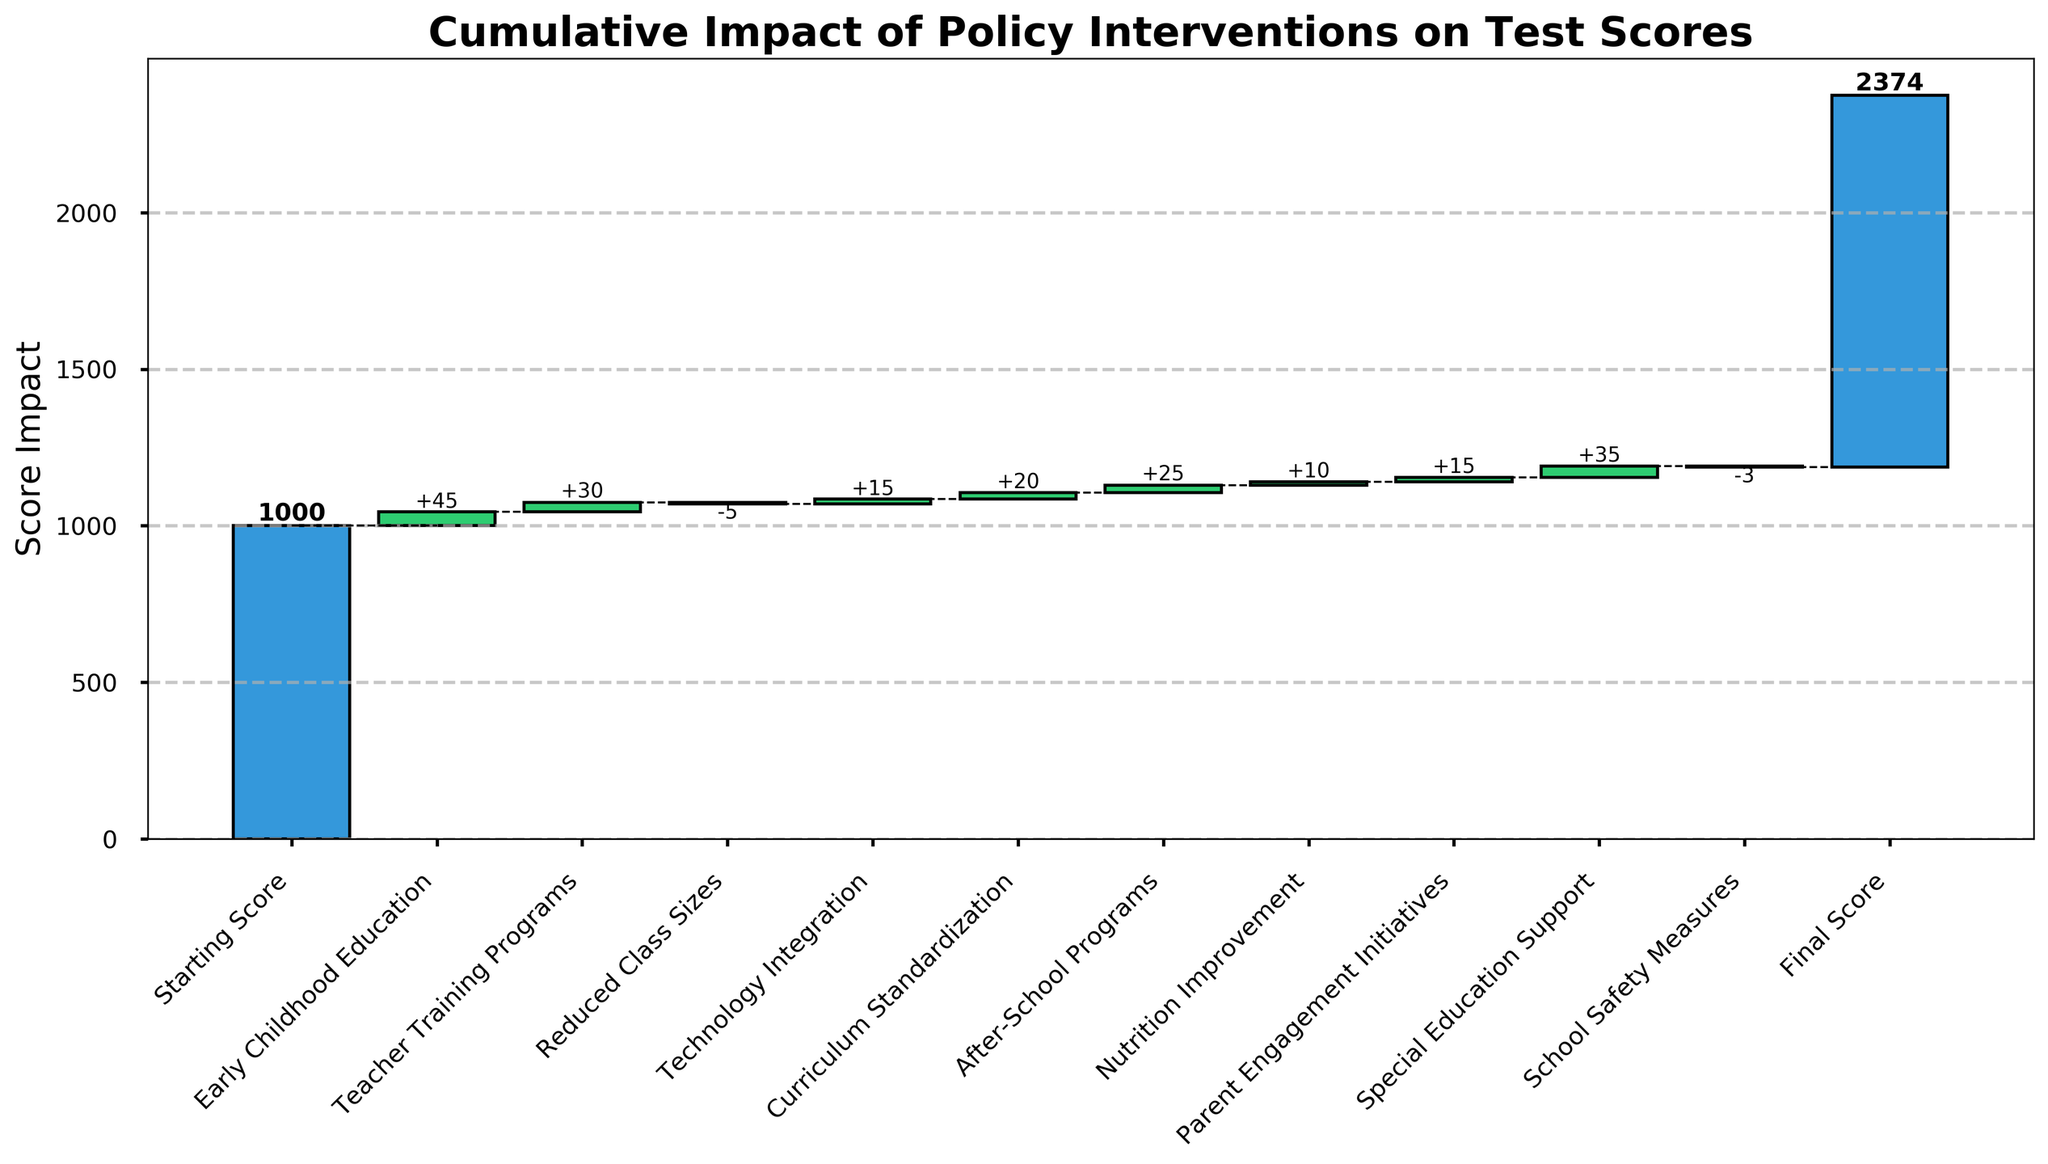What's the title of the chart? The title of the chart is the largest text at the top, which describes the purpose of the figure. It reads, "Cumulative Impact of Policy Interventions on Test Scores".
Answer: Cumulative Impact of Policy Interventions on Test Scores How many policy interventions are depicted in the figure? The figure lists each policy intervention along the x-axis. Counting all the bars on this axis including the starting and final scores, there are 11 items.
Answer: 11 Which policy intervention has the highest positive impact? By examining the height of the bars and their labels, we see that "Special Education Support" has the tallest bar among the intermediaries, indicating a positive impact of +35.
Answer: Special Education Support What is the initial score before any policy interventions? The first bar, labeled "Starting Score", indicates the initial score. The text within the bar confirms it is 1000.
Answer: 1000 What is the final score after all policy interventions? The last bar in the figure, which is labeled "Final Score", shows the cumulative result of all prior impacts. The label within this bar indicates a final score of 1187.
Answer: 1187 Which policy intervention is depicted to have a negative impact? By inspecting the color of the bars and their associated labels, "Reduced Class Sizes" is marked with a negative impact of -5, shown in red.
Answer: Reduced Class Sizes What is the cumulative impact of "Early Childhood Education", "Teacher Training Programs", and "After-School Programs" combined? Sum the impacts of these interventions: 45 (Early Childhood Education) + 30 (Teacher Training Programs) + 25 (After-School Programs) = 100.
Answer: 100 How does the impact of "Nutrition Improvement" compare to "Parent Engagement Initiatives"? Compare the values marked on the bars: "Nutrition Improvement" has an impact of +10 while "Parent Engagement Initiatives" has +15. Thus, "Parent Engagement Initiatives" has a higher positive impact by 5 points.
Answer: Parent Engagement Initiatives has higher impact by 5 What is the net impact of interventions that have negative contributions? Identify the interventions with negative impacts: "Reduced Class Sizes" (-5) and "School Safety Measures" (-3), and sum their impacts: -5 + (-3) = -8.
Answer: -8 Considering the final score, how much of a total increase do the interventions represent relative to the starting score? The final score is 1187 and the starting score is 1000. Subtract the starting score from the final score to find the total increase: 1187 - 1000 = 187.
Answer: 187 